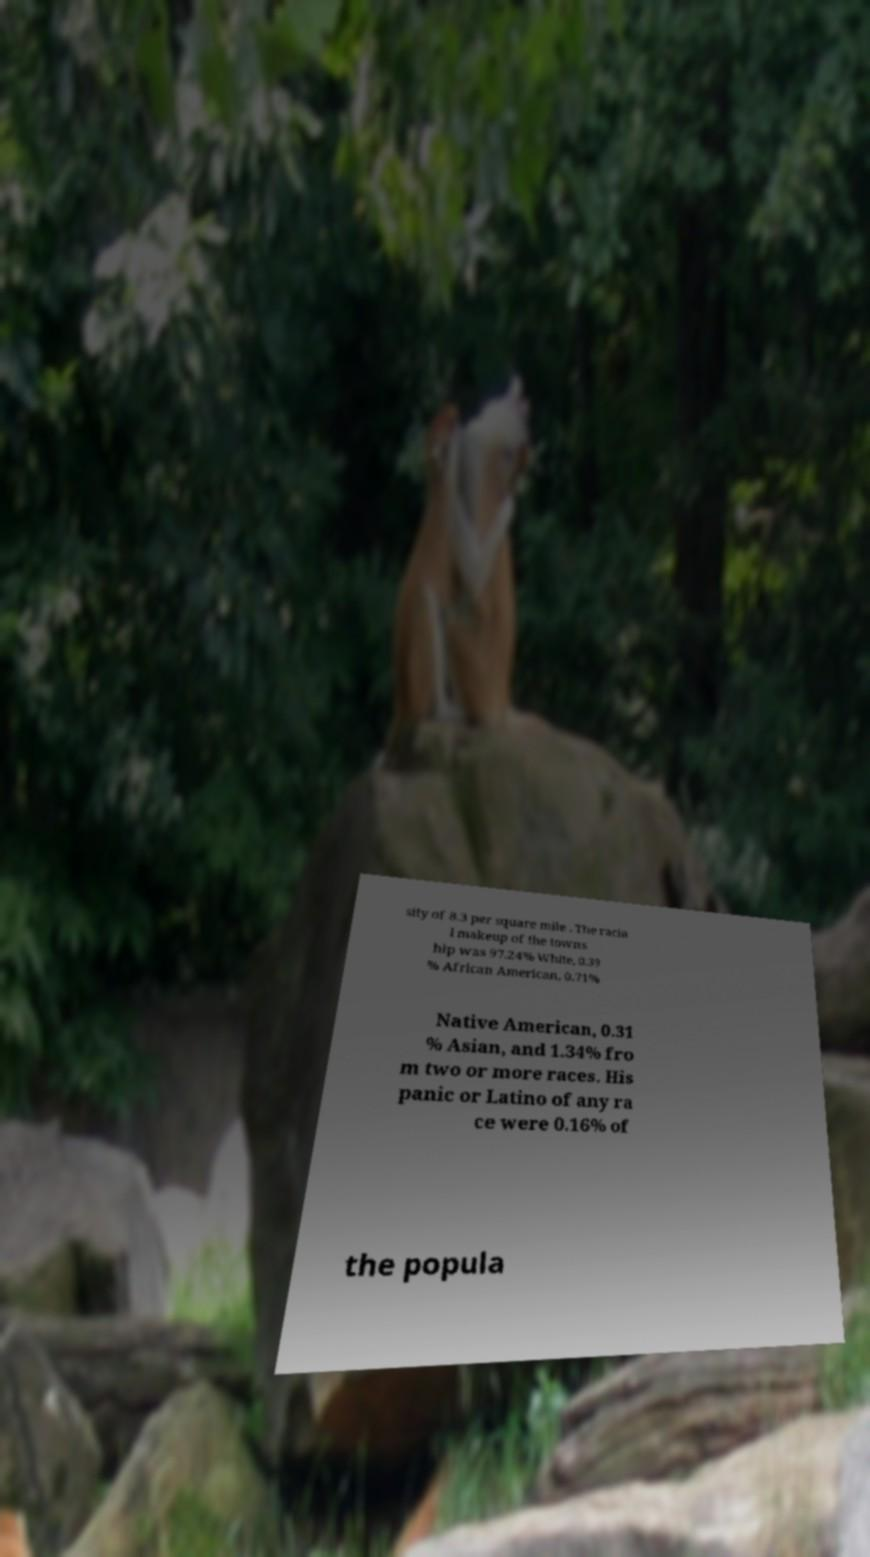Could you extract and type out the text from this image? sity of 8.3 per square mile . The racia l makeup of the towns hip was 97.24% White, 0.39 % African American, 0.71% Native American, 0.31 % Asian, and 1.34% fro m two or more races. His panic or Latino of any ra ce were 0.16% of the popula 